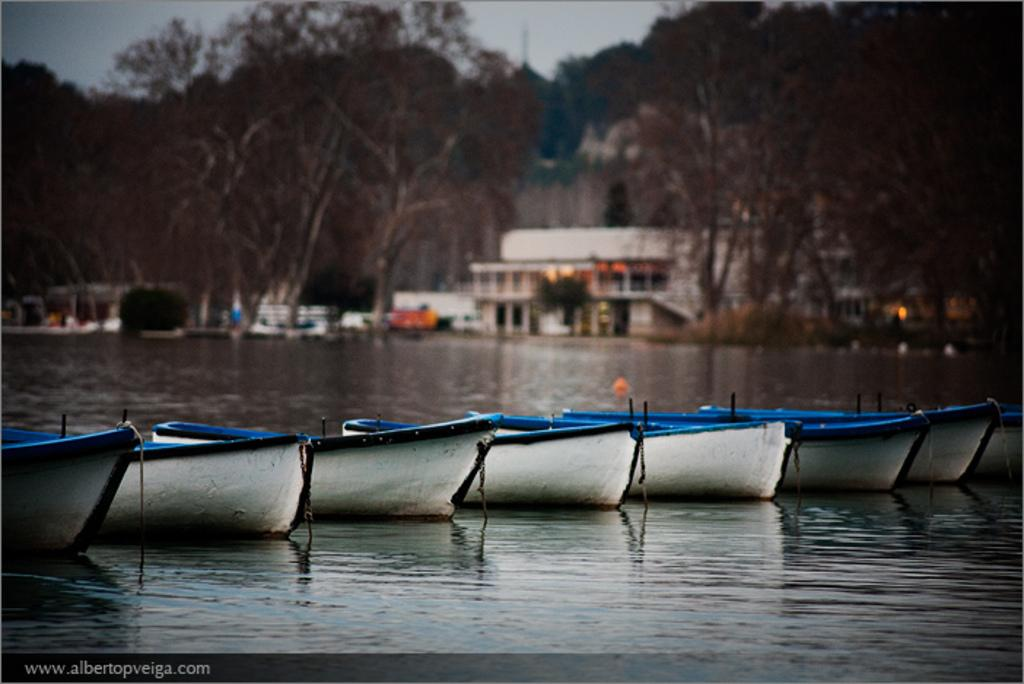What is the main subject of the image? The main subject of the image is boats. Can you describe the position of the boats in the image? The boats are above the water in the image. What can be seen in the background of the image? The background of the image is blurry, and there are buildings, trees, and the sky visible. What type of bone can be seen in the image? There is no bone present in the image; it features boats above the water with a blurry background. 